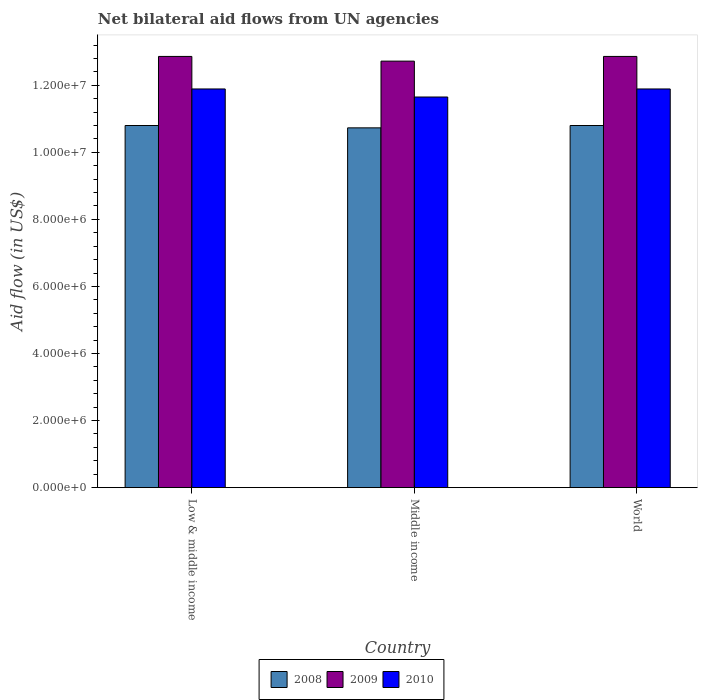Are the number of bars on each tick of the X-axis equal?
Give a very brief answer. Yes. How many bars are there on the 3rd tick from the left?
Provide a short and direct response. 3. In how many cases, is the number of bars for a given country not equal to the number of legend labels?
Offer a very short reply. 0. What is the net bilateral aid flow in 2008 in World?
Your answer should be very brief. 1.08e+07. Across all countries, what is the maximum net bilateral aid flow in 2009?
Offer a terse response. 1.29e+07. Across all countries, what is the minimum net bilateral aid flow in 2009?
Give a very brief answer. 1.27e+07. In which country was the net bilateral aid flow in 2010 maximum?
Your answer should be compact. Low & middle income. What is the total net bilateral aid flow in 2009 in the graph?
Make the answer very short. 3.84e+07. What is the difference between the net bilateral aid flow in 2009 in Middle income and the net bilateral aid flow in 2008 in World?
Your answer should be very brief. 1.92e+06. What is the average net bilateral aid flow in 2008 per country?
Your response must be concise. 1.08e+07. What is the difference between the net bilateral aid flow of/in 2008 and net bilateral aid flow of/in 2009 in Middle income?
Your response must be concise. -1.99e+06. What is the ratio of the net bilateral aid flow in 2008 in Low & middle income to that in Middle income?
Your answer should be very brief. 1.01. Is the net bilateral aid flow in 2009 in Low & middle income less than that in World?
Provide a short and direct response. No. What is the difference between the highest and the lowest net bilateral aid flow in 2008?
Offer a terse response. 7.00e+04. In how many countries, is the net bilateral aid flow in 2009 greater than the average net bilateral aid flow in 2009 taken over all countries?
Provide a short and direct response. 2. What does the 1st bar from the left in Middle income represents?
Your answer should be very brief. 2008. What is the difference between two consecutive major ticks on the Y-axis?
Offer a terse response. 2.00e+06. Does the graph contain grids?
Keep it short and to the point. No. Where does the legend appear in the graph?
Your response must be concise. Bottom center. What is the title of the graph?
Your answer should be very brief. Net bilateral aid flows from UN agencies. What is the label or title of the X-axis?
Offer a very short reply. Country. What is the label or title of the Y-axis?
Keep it short and to the point. Aid flow (in US$). What is the Aid flow (in US$) in 2008 in Low & middle income?
Your answer should be very brief. 1.08e+07. What is the Aid flow (in US$) of 2009 in Low & middle income?
Your response must be concise. 1.29e+07. What is the Aid flow (in US$) of 2010 in Low & middle income?
Provide a short and direct response. 1.19e+07. What is the Aid flow (in US$) of 2008 in Middle income?
Provide a succinct answer. 1.07e+07. What is the Aid flow (in US$) of 2009 in Middle income?
Your answer should be very brief. 1.27e+07. What is the Aid flow (in US$) of 2010 in Middle income?
Your answer should be very brief. 1.16e+07. What is the Aid flow (in US$) of 2008 in World?
Your answer should be compact. 1.08e+07. What is the Aid flow (in US$) in 2009 in World?
Ensure brevity in your answer.  1.29e+07. What is the Aid flow (in US$) of 2010 in World?
Your answer should be very brief. 1.19e+07. Across all countries, what is the maximum Aid flow (in US$) of 2008?
Provide a succinct answer. 1.08e+07. Across all countries, what is the maximum Aid flow (in US$) of 2009?
Your response must be concise. 1.29e+07. Across all countries, what is the maximum Aid flow (in US$) of 2010?
Offer a terse response. 1.19e+07. Across all countries, what is the minimum Aid flow (in US$) of 2008?
Provide a succinct answer. 1.07e+07. Across all countries, what is the minimum Aid flow (in US$) in 2009?
Offer a very short reply. 1.27e+07. Across all countries, what is the minimum Aid flow (in US$) of 2010?
Provide a short and direct response. 1.16e+07. What is the total Aid flow (in US$) of 2008 in the graph?
Offer a terse response. 3.23e+07. What is the total Aid flow (in US$) of 2009 in the graph?
Provide a succinct answer. 3.84e+07. What is the total Aid flow (in US$) in 2010 in the graph?
Make the answer very short. 3.54e+07. What is the difference between the Aid flow (in US$) of 2008 in Low & middle income and that in Middle income?
Keep it short and to the point. 7.00e+04. What is the difference between the Aid flow (in US$) of 2009 in Low & middle income and that in Middle income?
Your answer should be very brief. 1.40e+05. What is the difference between the Aid flow (in US$) of 2010 in Low & middle income and that in Middle income?
Make the answer very short. 2.40e+05. What is the difference between the Aid flow (in US$) in 2008 in Low & middle income and that in World?
Make the answer very short. 0. What is the difference between the Aid flow (in US$) in 2008 in Middle income and that in World?
Your response must be concise. -7.00e+04. What is the difference between the Aid flow (in US$) in 2008 in Low & middle income and the Aid flow (in US$) in 2009 in Middle income?
Provide a short and direct response. -1.92e+06. What is the difference between the Aid flow (in US$) of 2008 in Low & middle income and the Aid flow (in US$) of 2010 in Middle income?
Ensure brevity in your answer.  -8.50e+05. What is the difference between the Aid flow (in US$) of 2009 in Low & middle income and the Aid flow (in US$) of 2010 in Middle income?
Provide a succinct answer. 1.21e+06. What is the difference between the Aid flow (in US$) of 2008 in Low & middle income and the Aid flow (in US$) of 2009 in World?
Offer a very short reply. -2.06e+06. What is the difference between the Aid flow (in US$) of 2008 in Low & middle income and the Aid flow (in US$) of 2010 in World?
Give a very brief answer. -1.09e+06. What is the difference between the Aid flow (in US$) in 2009 in Low & middle income and the Aid flow (in US$) in 2010 in World?
Keep it short and to the point. 9.70e+05. What is the difference between the Aid flow (in US$) of 2008 in Middle income and the Aid flow (in US$) of 2009 in World?
Provide a succinct answer. -2.13e+06. What is the difference between the Aid flow (in US$) in 2008 in Middle income and the Aid flow (in US$) in 2010 in World?
Keep it short and to the point. -1.16e+06. What is the difference between the Aid flow (in US$) of 2009 in Middle income and the Aid flow (in US$) of 2010 in World?
Provide a succinct answer. 8.30e+05. What is the average Aid flow (in US$) in 2008 per country?
Ensure brevity in your answer.  1.08e+07. What is the average Aid flow (in US$) in 2009 per country?
Make the answer very short. 1.28e+07. What is the average Aid flow (in US$) of 2010 per country?
Offer a very short reply. 1.18e+07. What is the difference between the Aid flow (in US$) of 2008 and Aid flow (in US$) of 2009 in Low & middle income?
Your answer should be very brief. -2.06e+06. What is the difference between the Aid flow (in US$) in 2008 and Aid flow (in US$) in 2010 in Low & middle income?
Your response must be concise. -1.09e+06. What is the difference between the Aid flow (in US$) of 2009 and Aid flow (in US$) of 2010 in Low & middle income?
Offer a very short reply. 9.70e+05. What is the difference between the Aid flow (in US$) of 2008 and Aid flow (in US$) of 2009 in Middle income?
Your response must be concise. -1.99e+06. What is the difference between the Aid flow (in US$) of 2008 and Aid flow (in US$) of 2010 in Middle income?
Ensure brevity in your answer.  -9.20e+05. What is the difference between the Aid flow (in US$) in 2009 and Aid flow (in US$) in 2010 in Middle income?
Provide a short and direct response. 1.07e+06. What is the difference between the Aid flow (in US$) in 2008 and Aid flow (in US$) in 2009 in World?
Make the answer very short. -2.06e+06. What is the difference between the Aid flow (in US$) in 2008 and Aid flow (in US$) in 2010 in World?
Provide a short and direct response. -1.09e+06. What is the difference between the Aid flow (in US$) of 2009 and Aid flow (in US$) of 2010 in World?
Give a very brief answer. 9.70e+05. What is the ratio of the Aid flow (in US$) in 2008 in Low & middle income to that in Middle income?
Provide a short and direct response. 1.01. What is the ratio of the Aid flow (in US$) in 2010 in Low & middle income to that in Middle income?
Keep it short and to the point. 1.02. What is the ratio of the Aid flow (in US$) of 2010 in Low & middle income to that in World?
Ensure brevity in your answer.  1. What is the ratio of the Aid flow (in US$) of 2008 in Middle income to that in World?
Keep it short and to the point. 0.99. What is the ratio of the Aid flow (in US$) in 2009 in Middle income to that in World?
Make the answer very short. 0.99. What is the ratio of the Aid flow (in US$) in 2010 in Middle income to that in World?
Your answer should be compact. 0.98. What is the difference between the highest and the second highest Aid flow (in US$) in 2009?
Offer a very short reply. 0. What is the difference between the highest and the lowest Aid flow (in US$) in 2008?
Offer a very short reply. 7.00e+04. 